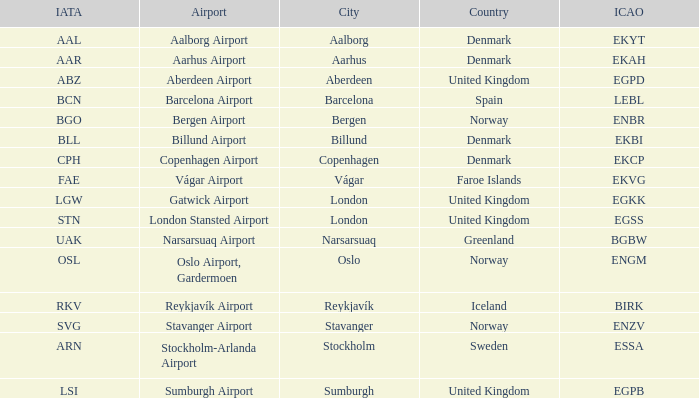What airport has an IATA of ARN? Stockholm-Arlanda Airport. 